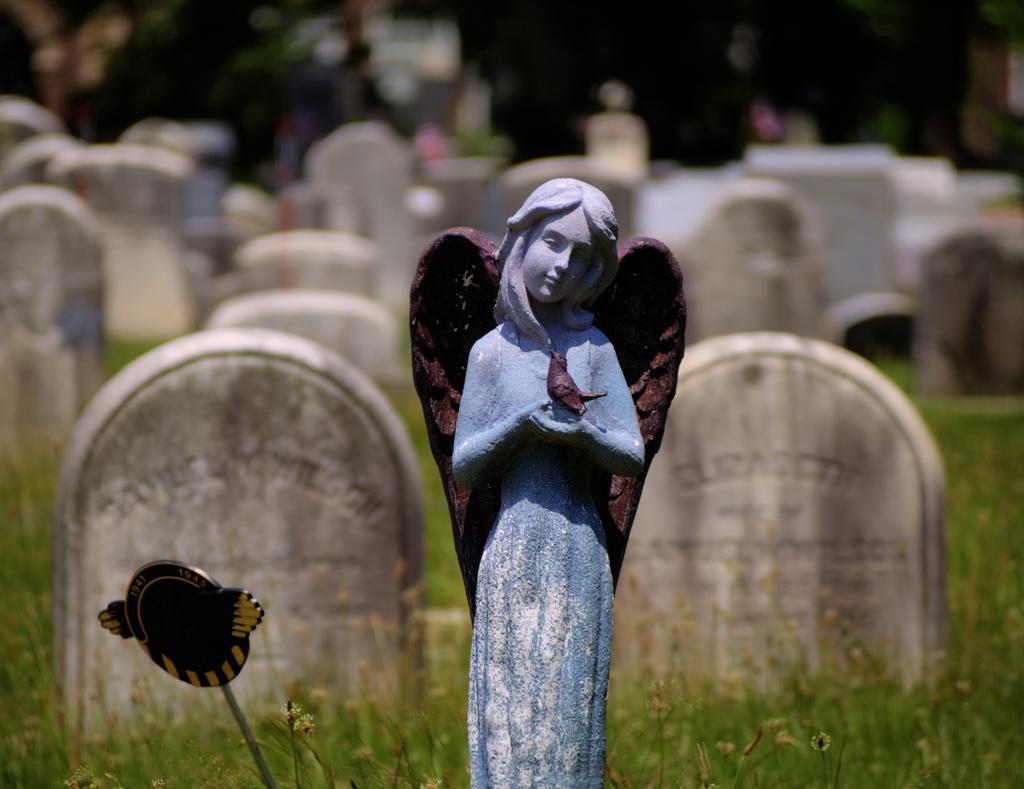What is the main subject of the image? There is a sculpture of a woman in the image. What is the bird doing in the image? A bird is present on the sculpture's hands. What type of natural environment can be seen in the image? There are many stones and grass visible in the image. What is the beggar doing with the queen's legs in the image? There is no beggar or queen present in the image; it features a sculpture of a woman with a bird on her hands. 